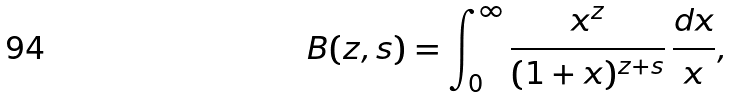Convert formula to latex. <formula><loc_0><loc_0><loc_500><loc_500>B ( z , s ) = \int _ { 0 } ^ { \infty } \frac { x ^ { z } } { ( 1 + x ) ^ { z + s } } \, \frac { d x } { x } ,</formula> 